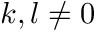Convert formula to latex. <formula><loc_0><loc_0><loc_500><loc_500>k , l \neq 0</formula> 